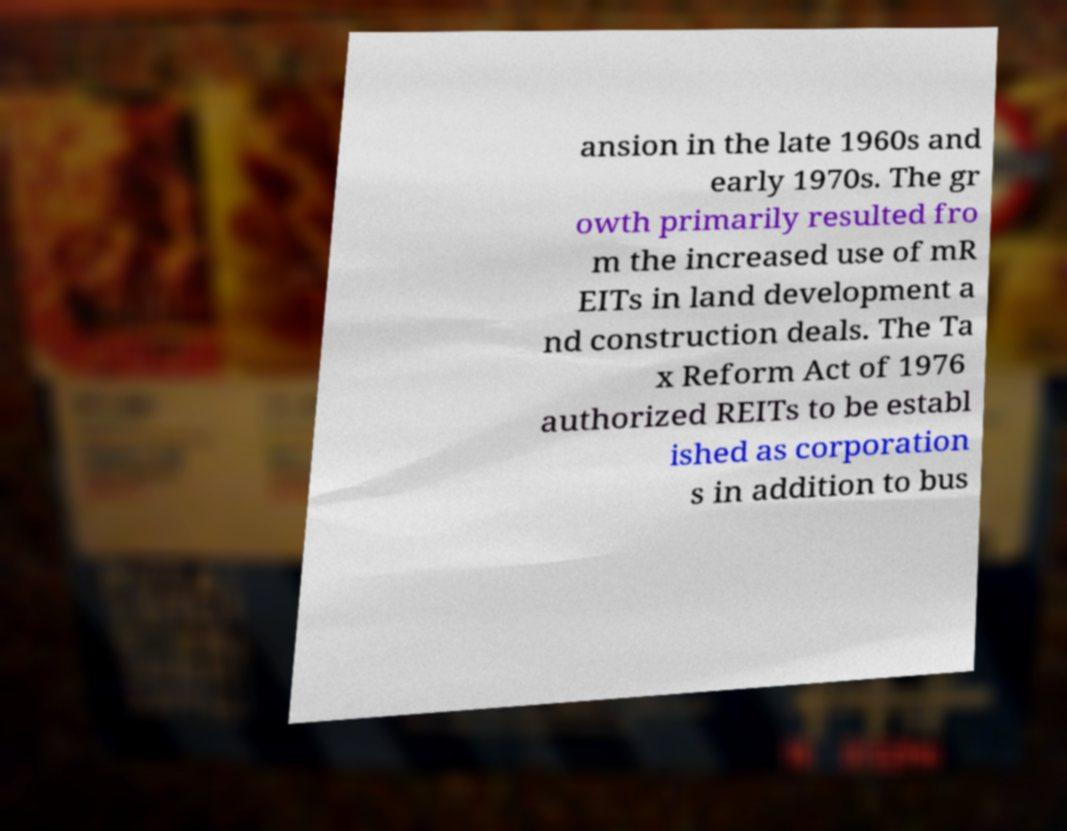Please identify and transcribe the text found in this image. ansion in the late 1960s and early 1970s. The gr owth primarily resulted fro m the increased use of mR EITs in land development a nd construction deals. The Ta x Reform Act of 1976 authorized REITs to be establ ished as corporation s in addition to bus 